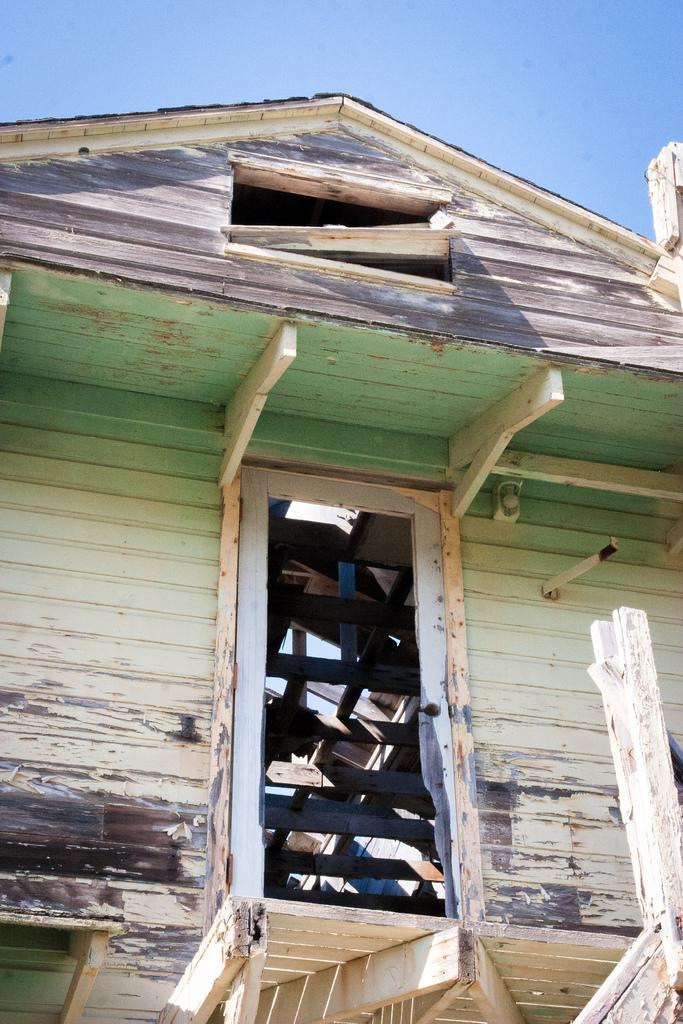What structure is present in the image? There is a shed in the image. What can be seen in the background of the image? The sky is visible in the background of the image. What type of orange is being used as a ship in the image? There is no orange or ship present in the image; it only features a shed and the sky. 